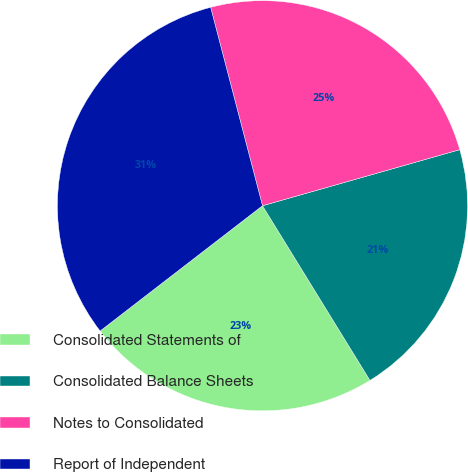Convert chart to OTSL. <chart><loc_0><loc_0><loc_500><loc_500><pie_chart><fcel>Consolidated Statements of<fcel>Consolidated Balance Sheets<fcel>Notes to Consolidated<fcel>Report of Independent<nl><fcel>23.32%<fcel>20.63%<fcel>24.66%<fcel>31.39%<nl></chart> 